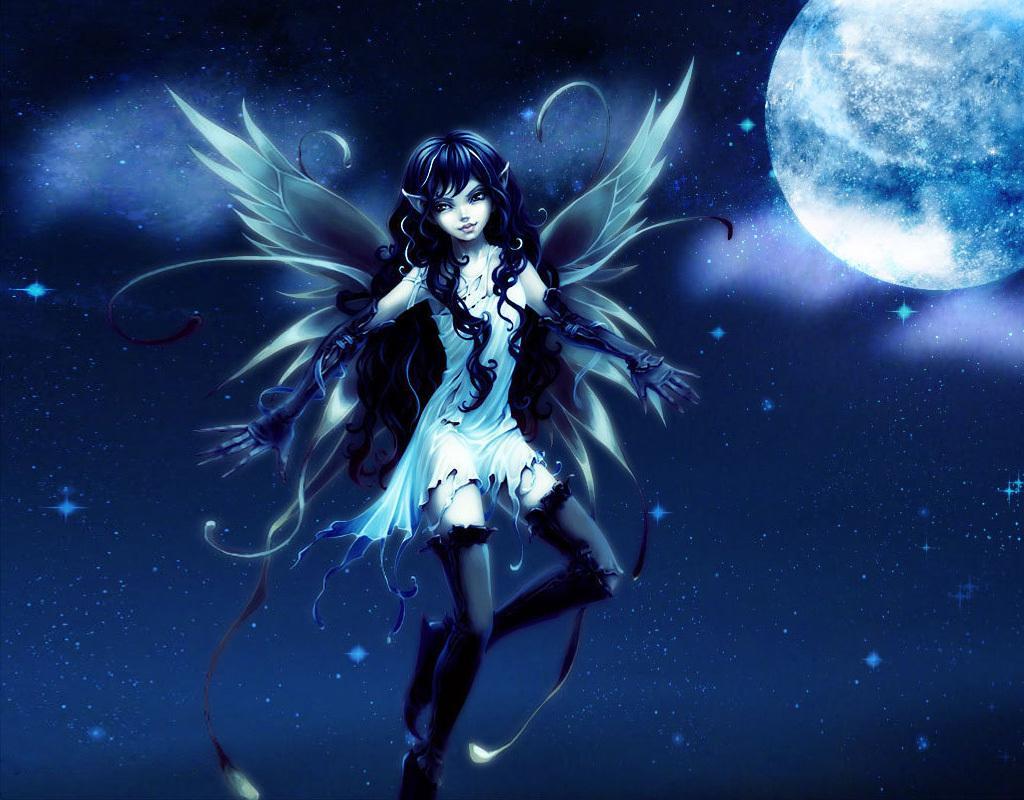Can you describe this image briefly? Here this is a animated image, in which we can see depiction picture of a woman with wings flying in air and we can also see moon and star in the sky. 